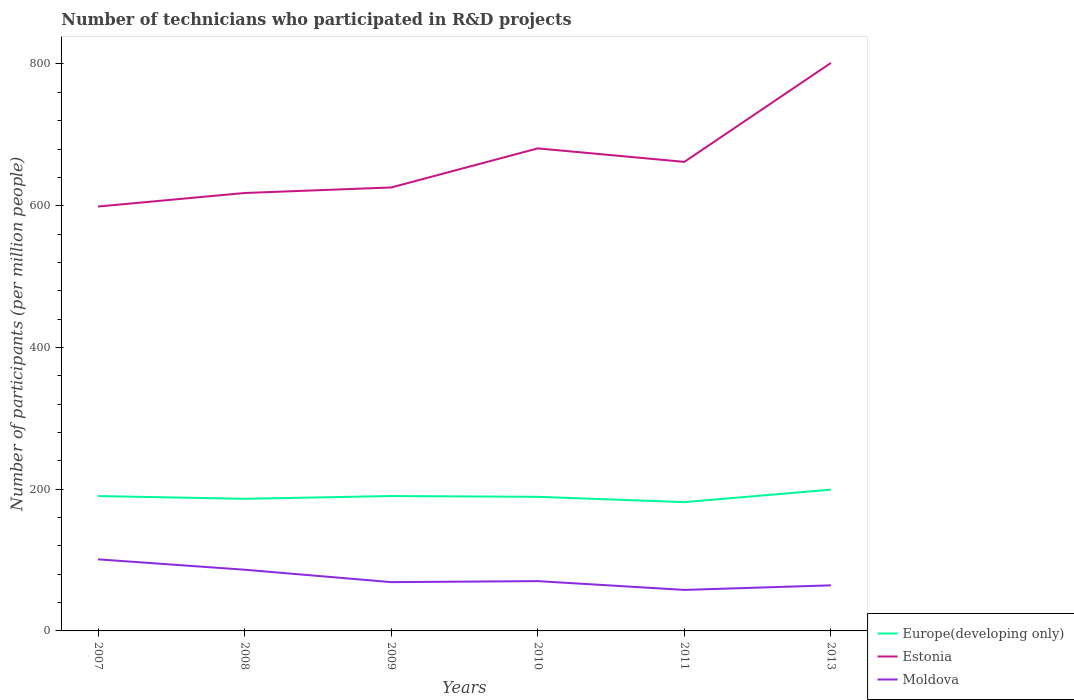Across all years, what is the maximum number of technicians who participated in R&D projects in Moldova?
Provide a short and direct response. 57.87. In which year was the number of technicians who participated in R&D projects in Moldova maximum?
Ensure brevity in your answer.  2011. What is the total number of technicians who participated in R&D projects in Europe(developing only) in the graph?
Provide a short and direct response. -2.8. What is the difference between the highest and the second highest number of technicians who participated in R&D projects in Estonia?
Provide a short and direct response. 202.63. What is the difference between the highest and the lowest number of technicians who participated in R&D projects in Moldova?
Make the answer very short. 2. Is the number of technicians who participated in R&D projects in Europe(developing only) strictly greater than the number of technicians who participated in R&D projects in Estonia over the years?
Offer a very short reply. Yes. How many lines are there?
Make the answer very short. 3. What is the difference between two consecutive major ticks on the Y-axis?
Make the answer very short. 200. Are the values on the major ticks of Y-axis written in scientific E-notation?
Your response must be concise. No. Does the graph contain grids?
Your response must be concise. No. Where does the legend appear in the graph?
Keep it short and to the point. Bottom right. How many legend labels are there?
Make the answer very short. 3. What is the title of the graph?
Provide a succinct answer. Number of technicians who participated in R&D projects. What is the label or title of the Y-axis?
Provide a succinct answer. Number of participants (per million people). What is the Number of participants (per million people) in Europe(developing only) in 2007?
Keep it short and to the point. 190.32. What is the Number of participants (per million people) in Estonia in 2007?
Your answer should be compact. 598.85. What is the Number of participants (per million people) in Moldova in 2007?
Offer a very short reply. 101.01. What is the Number of participants (per million people) of Europe(developing only) in 2008?
Keep it short and to the point. 186.43. What is the Number of participants (per million people) in Estonia in 2008?
Provide a short and direct response. 617.94. What is the Number of participants (per million people) in Moldova in 2008?
Ensure brevity in your answer.  86.35. What is the Number of participants (per million people) of Europe(developing only) in 2009?
Offer a terse response. 190.35. What is the Number of participants (per million people) in Estonia in 2009?
Offer a very short reply. 625.74. What is the Number of participants (per million people) in Moldova in 2009?
Give a very brief answer. 68.85. What is the Number of participants (per million people) of Europe(developing only) in 2010?
Give a very brief answer. 189.23. What is the Number of participants (per million people) of Estonia in 2010?
Make the answer very short. 680.89. What is the Number of participants (per million people) of Moldova in 2010?
Offer a terse response. 70.27. What is the Number of participants (per million people) in Europe(developing only) in 2011?
Offer a terse response. 181.74. What is the Number of participants (per million people) of Estonia in 2011?
Ensure brevity in your answer.  661.86. What is the Number of participants (per million people) of Moldova in 2011?
Make the answer very short. 57.87. What is the Number of participants (per million people) of Europe(developing only) in 2013?
Give a very brief answer. 199.34. What is the Number of participants (per million people) in Estonia in 2013?
Your response must be concise. 801.48. What is the Number of participants (per million people) in Moldova in 2013?
Keep it short and to the point. 64.31. Across all years, what is the maximum Number of participants (per million people) in Europe(developing only)?
Make the answer very short. 199.34. Across all years, what is the maximum Number of participants (per million people) in Estonia?
Keep it short and to the point. 801.48. Across all years, what is the maximum Number of participants (per million people) in Moldova?
Provide a succinct answer. 101.01. Across all years, what is the minimum Number of participants (per million people) in Europe(developing only)?
Offer a very short reply. 181.74. Across all years, what is the minimum Number of participants (per million people) in Estonia?
Provide a succinct answer. 598.85. Across all years, what is the minimum Number of participants (per million people) of Moldova?
Keep it short and to the point. 57.87. What is the total Number of participants (per million people) in Europe(developing only) in the graph?
Provide a succinct answer. 1137.4. What is the total Number of participants (per million people) of Estonia in the graph?
Make the answer very short. 3986.77. What is the total Number of participants (per million people) in Moldova in the graph?
Keep it short and to the point. 448.66. What is the difference between the Number of participants (per million people) in Europe(developing only) in 2007 and that in 2008?
Provide a succinct answer. 3.89. What is the difference between the Number of participants (per million people) in Estonia in 2007 and that in 2008?
Offer a terse response. -19.08. What is the difference between the Number of participants (per million people) of Moldova in 2007 and that in 2008?
Your answer should be compact. 14.66. What is the difference between the Number of participants (per million people) of Europe(developing only) in 2007 and that in 2009?
Provide a succinct answer. -0.04. What is the difference between the Number of participants (per million people) in Estonia in 2007 and that in 2009?
Your response must be concise. -26.89. What is the difference between the Number of participants (per million people) in Moldova in 2007 and that in 2009?
Your response must be concise. 32.16. What is the difference between the Number of participants (per million people) of Europe(developing only) in 2007 and that in 2010?
Provide a short and direct response. 1.09. What is the difference between the Number of participants (per million people) of Estonia in 2007 and that in 2010?
Your answer should be compact. -82.03. What is the difference between the Number of participants (per million people) in Moldova in 2007 and that in 2010?
Provide a succinct answer. 30.74. What is the difference between the Number of participants (per million people) in Europe(developing only) in 2007 and that in 2011?
Offer a very short reply. 8.58. What is the difference between the Number of participants (per million people) in Estonia in 2007 and that in 2011?
Give a very brief answer. -63.01. What is the difference between the Number of participants (per million people) in Moldova in 2007 and that in 2011?
Give a very brief answer. 43.13. What is the difference between the Number of participants (per million people) of Europe(developing only) in 2007 and that in 2013?
Your response must be concise. -9.02. What is the difference between the Number of participants (per million people) of Estonia in 2007 and that in 2013?
Keep it short and to the point. -202.63. What is the difference between the Number of participants (per million people) of Moldova in 2007 and that in 2013?
Offer a terse response. 36.69. What is the difference between the Number of participants (per million people) in Europe(developing only) in 2008 and that in 2009?
Provide a short and direct response. -3.93. What is the difference between the Number of participants (per million people) in Estonia in 2008 and that in 2009?
Your answer should be compact. -7.8. What is the difference between the Number of participants (per million people) of Moldova in 2008 and that in 2009?
Make the answer very short. 17.5. What is the difference between the Number of participants (per million people) of Europe(developing only) in 2008 and that in 2010?
Your response must be concise. -2.8. What is the difference between the Number of participants (per million people) of Estonia in 2008 and that in 2010?
Offer a very short reply. -62.95. What is the difference between the Number of participants (per million people) of Moldova in 2008 and that in 2010?
Your response must be concise. 16.08. What is the difference between the Number of participants (per million people) in Europe(developing only) in 2008 and that in 2011?
Make the answer very short. 4.68. What is the difference between the Number of participants (per million people) in Estonia in 2008 and that in 2011?
Offer a terse response. -43.93. What is the difference between the Number of participants (per million people) of Moldova in 2008 and that in 2011?
Offer a terse response. 28.48. What is the difference between the Number of participants (per million people) in Europe(developing only) in 2008 and that in 2013?
Offer a very short reply. -12.92. What is the difference between the Number of participants (per million people) in Estonia in 2008 and that in 2013?
Make the answer very short. -183.55. What is the difference between the Number of participants (per million people) of Moldova in 2008 and that in 2013?
Provide a short and direct response. 22.04. What is the difference between the Number of participants (per million people) of Europe(developing only) in 2009 and that in 2010?
Make the answer very short. 1.13. What is the difference between the Number of participants (per million people) in Estonia in 2009 and that in 2010?
Offer a very short reply. -55.14. What is the difference between the Number of participants (per million people) in Moldova in 2009 and that in 2010?
Your answer should be compact. -1.42. What is the difference between the Number of participants (per million people) in Europe(developing only) in 2009 and that in 2011?
Your response must be concise. 8.61. What is the difference between the Number of participants (per million people) of Estonia in 2009 and that in 2011?
Your answer should be compact. -36.12. What is the difference between the Number of participants (per million people) of Moldova in 2009 and that in 2011?
Your answer should be very brief. 10.98. What is the difference between the Number of participants (per million people) of Europe(developing only) in 2009 and that in 2013?
Your answer should be very brief. -8.99. What is the difference between the Number of participants (per million people) of Estonia in 2009 and that in 2013?
Your response must be concise. -175.74. What is the difference between the Number of participants (per million people) of Moldova in 2009 and that in 2013?
Your response must be concise. 4.54. What is the difference between the Number of participants (per million people) of Europe(developing only) in 2010 and that in 2011?
Keep it short and to the point. 7.49. What is the difference between the Number of participants (per million people) in Estonia in 2010 and that in 2011?
Your response must be concise. 19.02. What is the difference between the Number of participants (per million people) in Moldova in 2010 and that in 2011?
Your answer should be very brief. 12.39. What is the difference between the Number of participants (per million people) of Europe(developing only) in 2010 and that in 2013?
Give a very brief answer. -10.11. What is the difference between the Number of participants (per million people) of Estonia in 2010 and that in 2013?
Give a very brief answer. -120.6. What is the difference between the Number of participants (per million people) of Moldova in 2010 and that in 2013?
Your answer should be compact. 5.95. What is the difference between the Number of participants (per million people) in Europe(developing only) in 2011 and that in 2013?
Provide a succinct answer. -17.6. What is the difference between the Number of participants (per million people) in Estonia in 2011 and that in 2013?
Ensure brevity in your answer.  -139.62. What is the difference between the Number of participants (per million people) in Moldova in 2011 and that in 2013?
Make the answer very short. -6.44. What is the difference between the Number of participants (per million people) in Europe(developing only) in 2007 and the Number of participants (per million people) in Estonia in 2008?
Offer a terse response. -427.62. What is the difference between the Number of participants (per million people) of Europe(developing only) in 2007 and the Number of participants (per million people) of Moldova in 2008?
Ensure brevity in your answer.  103.97. What is the difference between the Number of participants (per million people) of Estonia in 2007 and the Number of participants (per million people) of Moldova in 2008?
Your answer should be compact. 512.5. What is the difference between the Number of participants (per million people) in Europe(developing only) in 2007 and the Number of participants (per million people) in Estonia in 2009?
Offer a very short reply. -435.43. What is the difference between the Number of participants (per million people) in Europe(developing only) in 2007 and the Number of participants (per million people) in Moldova in 2009?
Your answer should be compact. 121.47. What is the difference between the Number of participants (per million people) of Estonia in 2007 and the Number of participants (per million people) of Moldova in 2009?
Your response must be concise. 530. What is the difference between the Number of participants (per million people) of Europe(developing only) in 2007 and the Number of participants (per million people) of Estonia in 2010?
Provide a short and direct response. -490.57. What is the difference between the Number of participants (per million people) in Europe(developing only) in 2007 and the Number of participants (per million people) in Moldova in 2010?
Your answer should be very brief. 120.05. What is the difference between the Number of participants (per million people) in Estonia in 2007 and the Number of participants (per million people) in Moldova in 2010?
Offer a very short reply. 528.59. What is the difference between the Number of participants (per million people) of Europe(developing only) in 2007 and the Number of participants (per million people) of Estonia in 2011?
Make the answer very short. -471.55. What is the difference between the Number of participants (per million people) in Europe(developing only) in 2007 and the Number of participants (per million people) in Moldova in 2011?
Provide a succinct answer. 132.44. What is the difference between the Number of participants (per million people) in Estonia in 2007 and the Number of participants (per million people) in Moldova in 2011?
Give a very brief answer. 540.98. What is the difference between the Number of participants (per million people) of Europe(developing only) in 2007 and the Number of participants (per million people) of Estonia in 2013?
Ensure brevity in your answer.  -611.17. What is the difference between the Number of participants (per million people) of Europe(developing only) in 2007 and the Number of participants (per million people) of Moldova in 2013?
Offer a terse response. 126. What is the difference between the Number of participants (per million people) in Estonia in 2007 and the Number of participants (per million people) in Moldova in 2013?
Offer a terse response. 534.54. What is the difference between the Number of participants (per million people) of Europe(developing only) in 2008 and the Number of participants (per million people) of Estonia in 2009?
Make the answer very short. -439.32. What is the difference between the Number of participants (per million people) of Europe(developing only) in 2008 and the Number of participants (per million people) of Moldova in 2009?
Offer a very short reply. 117.57. What is the difference between the Number of participants (per million people) of Estonia in 2008 and the Number of participants (per million people) of Moldova in 2009?
Provide a short and direct response. 549.09. What is the difference between the Number of participants (per million people) of Europe(developing only) in 2008 and the Number of participants (per million people) of Estonia in 2010?
Your response must be concise. -494.46. What is the difference between the Number of participants (per million people) of Europe(developing only) in 2008 and the Number of participants (per million people) of Moldova in 2010?
Keep it short and to the point. 116.16. What is the difference between the Number of participants (per million people) in Estonia in 2008 and the Number of participants (per million people) in Moldova in 2010?
Offer a very short reply. 547.67. What is the difference between the Number of participants (per million people) in Europe(developing only) in 2008 and the Number of participants (per million people) in Estonia in 2011?
Make the answer very short. -475.44. What is the difference between the Number of participants (per million people) in Europe(developing only) in 2008 and the Number of participants (per million people) in Moldova in 2011?
Your response must be concise. 128.55. What is the difference between the Number of participants (per million people) of Estonia in 2008 and the Number of participants (per million people) of Moldova in 2011?
Your answer should be compact. 560.06. What is the difference between the Number of participants (per million people) of Europe(developing only) in 2008 and the Number of participants (per million people) of Estonia in 2013?
Your answer should be very brief. -615.06. What is the difference between the Number of participants (per million people) of Europe(developing only) in 2008 and the Number of participants (per million people) of Moldova in 2013?
Give a very brief answer. 122.11. What is the difference between the Number of participants (per million people) of Estonia in 2008 and the Number of participants (per million people) of Moldova in 2013?
Offer a very short reply. 553.62. What is the difference between the Number of participants (per million people) in Europe(developing only) in 2009 and the Number of participants (per million people) in Estonia in 2010?
Provide a succinct answer. -490.53. What is the difference between the Number of participants (per million people) of Europe(developing only) in 2009 and the Number of participants (per million people) of Moldova in 2010?
Your response must be concise. 120.09. What is the difference between the Number of participants (per million people) in Estonia in 2009 and the Number of participants (per million people) in Moldova in 2010?
Keep it short and to the point. 555.48. What is the difference between the Number of participants (per million people) of Europe(developing only) in 2009 and the Number of participants (per million people) of Estonia in 2011?
Provide a short and direct response. -471.51. What is the difference between the Number of participants (per million people) of Europe(developing only) in 2009 and the Number of participants (per million people) of Moldova in 2011?
Offer a terse response. 132.48. What is the difference between the Number of participants (per million people) of Estonia in 2009 and the Number of participants (per million people) of Moldova in 2011?
Keep it short and to the point. 567.87. What is the difference between the Number of participants (per million people) in Europe(developing only) in 2009 and the Number of participants (per million people) in Estonia in 2013?
Your response must be concise. -611.13. What is the difference between the Number of participants (per million people) of Europe(developing only) in 2009 and the Number of participants (per million people) of Moldova in 2013?
Provide a short and direct response. 126.04. What is the difference between the Number of participants (per million people) in Estonia in 2009 and the Number of participants (per million people) in Moldova in 2013?
Your response must be concise. 561.43. What is the difference between the Number of participants (per million people) of Europe(developing only) in 2010 and the Number of participants (per million people) of Estonia in 2011?
Your answer should be compact. -472.64. What is the difference between the Number of participants (per million people) in Europe(developing only) in 2010 and the Number of participants (per million people) in Moldova in 2011?
Your response must be concise. 131.35. What is the difference between the Number of participants (per million people) in Estonia in 2010 and the Number of participants (per million people) in Moldova in 2011?
Keep it short and to the point. 623.01. What is the difference between the Number of participants (per million people) of Europe(developing only) in 2010 and the Number of participants (per million people) of Estonia in 2013?
Offer a very short reply. -612.26. What is the difference between the Number of participants (per million people) in Europe(developing only) in 2010 and the Number of participants (per million people) in Moldova in 2013?
Make the answer very short. 124.91. What is the difference between the Number of participants (per million people) in Estonia in 2010 and the Number of participants (per million people) in Moldova in 2013?
Offer a very short reply. 616.57. What is the difference between the Number of participants (per million people) of Europe(developing only) in 2011 and the Number of participants (per million people) of Estonia in 2013?
Your answer should be compact. -619.74. What is the difference between the Number of participants (per million people) of Europe(developing only) in 2011 and the Number of participants (per million people) of Moldova in 2013?
Give a very brief answer. 117.43. What is the difference between the Number of participants (per million people) in Estonia in 2011 and the Number of participants (per million people) in Moldova in 2013?
Give a very brief answer. 597.55. What is the average Number of participants (per million people) of Europe(developing only) per year?
Offer a terse response. 189.57. What is the average Number of participants (per million people) in Estonia per year?
Keep it short and to the point. 664.46. What is the average Number of participants (per million people) of Moldova per year?
Your answer should be very brief. 74.78. In the year 2007, what is the difference between the Number of participants (per million people) in Europe(developing only) and Number of participants (per million people) in Estonia?
Provide a succinct answer. -408.54. In the year 2007, what is the difference between the Number of participants (per million people) of Europe(developing only) and Number of participants (per million people) of Moldova?
Your response must be concise. 89.31. In the year 2007, what is the difference between the Number of participants (per million people) in Estonia and Number of participants (per million people) in Moldova?
Make the answer very short. 497.85. In the year 2008, what is the difference between the Number of participants (per million people) in Europe(developing only) and Number of participants (per million people) in Estonia?
Offer a very short reply. -431.51. In the year 2008, what is the difference between the Number of participants (per million people) of Europe(developing only) and Number of participants (per million people) of Moldova?
Your answer should be compact. 100.08. In the year 2008, what is the difference between the Number of participants (per million people) of Estonia and Number of participants (per million people) of Moldova?
Offer a terse response. 531.59. In the year 2009, what is the difference between the Number of participants (per million people) of Europe(developing only) and Number of participants (per million people) of Estonia?
Provide a short and direct response. -435.39. In the year 2009, what is the difference between the Number of participants (per million people) in Europe(developing only) and Number of participants (per million people) in Moldova?
Your response must be concise. 121.5. In the year 2009, what is the difference between the Number of participants (per million people) in Estonia and Number of participants (per million people) in Moldova?
Make the answer very short. 556.89. In the year 2010, what is the difference between the Number of participants (per million people) of Europe(developing only) and Number of participants (per million people) of Estonia?
Keep it short and to the point. -491.66. In the year 2010, what is the difference between the Number of participants (per million people) of Europe(developing only) and Number of participants (per million people) of Moldova?
Your answer should be compact. 118.96. In the year 2010, what is the difference between the Number of participants (per million people) of Estonia and Number of participants (per million people) of Moldova?
Offer a very short reply. 610.62. In the year 2011, what is the difference between the Number of participants (per million people) in Europe(developing only) and Number of participants (per million people) in Estonia?
Provide a short and direct response. -480.12. In the year 2011, what is the difference between the Number of participants (per million people) of Europe(developing only) and Number of participants (per million people) of Moldova?
Provide a short and direct response. 123.87. In the year 2011, what is the difference between the Number of participants (per million people) in Estonia and Number of participants (per million people) in Moldova?
Offer a terse response. 603.99. In the year 2013, what is the difference between the Number of participants (per million people) of Europe(developing only) and Number of participants (per million people) of Estonia?
Your answer should be compact. -602.14. In the year 2013, what is the difference between the Number of participants (per million people) in Europe(developing only) and Number of participants (per million people) in Moldova?
Ensure brevity in your answer.  135.03. In the year 2013, what is the difference between the Number of participants (per million people) in Estonia and Number of participants (per million people) in Moldova?
Your answer should be compact. 737.17. What is the ratio of the Number of participants (per million people) of Europe(developing only) in 2007 to that in 2008?
Provide a short and direct response. 1.02. What is the ratio of the Number of participants (per million people) of Estonia in 2007 to that in 2008?
Make the answer very short. 0.97. What is the ratio of the Number of participants (per million people) of Moldova in 2007 to that in 2008?
Your response must be concise. 1.17. What is the ratio of the Number of participants (per million people) of Europe(developing only) in 2007 to that in 2009?
Offer a terse response. 1. What is the ratio of the Number of participants (per million people) in Estonia in 2007 to that in 2009?
Provide a succinct answer. 0.96. What is the ratio of the Number of participants (per million people) of Moldova in 2007 to that in 2009?
Offer a terse response. 1.47. What is the ratio of the Number of participants (per million people) in Europe(developing only) in 2007 to that in 2010?
Provide a short and direct response. 1.01. What is the ratio of the Number of participants (per million people) in Estonia in 2007 to that in 2010?
Give a very brief answer. 0.88. What is the ratio of the Number of participants (per million people) in Moldova in 2007 to that in 2010?
Make the answer very short. 1.44. What is the ratio of the Number of participants (per million people) of Europe(developing only) in 2007 to that in 2011?
Your response must be concise. 1.05. What is the ratio of the Number of participants (per million people) in Estonia in 2007 to that in 2011?
Offer a very short reply. 0.9. What is the ratio of the Number of participants (per million people) of Moldova in 2007 to that in 2011?
Your answer should be very brief. 1.75. What is the ratio of the Number of participants (per million people) in Europe(developing only) in 2007 to that in 2013?
Your answer should be compact. 0.95. What is the ratio of the Number of participants (per million people) in Estonia in 2007 to that in 2013?
Offer a terse response. 0.75. What is the ratio of the Number of participants (per million people) in Moldova in 2007 to that in 2013?
Your answer should be very brief. 1.57. What is the ratio of the Number of participants (per million people) in Europe(developing only) in 2008 to that in 2009?
Your answer should be very brief. 0.98. What is the ratio of the Number of participants (per million people) in Estonia in 2008 to that in 2009?
Your answer should be very brief. 0.99. What is the ratio of the Number of participants (per million people) of Moldova in 2008 to that in 2009?
Your response must be concise. 1.25. What is the ratio of the Number of participants (per million people) of Europe(developing only) in 2008 to that in 2010?
Keep it short and to the point. 0.99. What is the ratio of the Number of participants (per million people) of Estonia in 2008 to that in 2010?
Your answer should be compact. 0.91. What is the ratio of the Number of participants (per million people) in Moldova in 2008 to that in 2010?
Your answer should be compact. 1.23. What is the ratio of the Number of participants (per million people) in Europe(developing only) in 2008 to that in 2011?
Offer a very short reply. 1.03. What is the ratio of the Number of participants (per million people) in Estonia in 2008 to that in 2011?
Offer a terse response. 0.93. What is the ratio of the Number of participants (per million people) of Moldova in 2008 to that in 2011?
Provide a succinct answer. 1.49. What is the ratio of the Number of participants (per million people) of Europe(developing only) in 2008 to that in 2013?
Make the answer very short. 0.94. What is the ratio of the Number of participants (per million people) in Estonia in 2008 to that in 2013?
Provide a succinct answer. 0.77. What is the ratio of the Number of participants (per million people) of Moldova in 2008 to that in 2013?
Ensure brevity in your answer.  1.34. What is the ratio of the Number of participants (per million people) of Estonia in 2009 to that in 2010?
Give a very brief answer. 0.92. What is the ratio of the Number of participants (per million people) of Moldova in 2009 to that in 2010?
Keep it short and to the point. 0.98. What is the ratio of the Number of participants (per million people) of Europe(developing only) in 2009 to that in 2011?
Your response must be concise. 1.05. What is the ratio of the Number of participants (per million people) of Estonia in 2009 to that in 2011?
Your answer should be very brief. 0.95. What is the ratio of the Number of participants (per million people) of Moldova in 2009 to that in 2011?
Make the answer very short. 1.19. What is the ratio of the Number of participants (per million people) of Europe(developing only) in 2009 to that in 2013?
Offer a terse response. 0.95. What is the ratio of the Number of participants (per million people) in Estonia in 2009 to that in 2013?
Your answer should be compact. 0.78. What is the ratio of the Number of participants (per million people) of Moldova in 2009 to that in 2013?
Provide a short and direct response. 1.07. What is the ratio of the Number of participants (per million people) in Europe(developing only) in 2010 to that in 2011?
Your answer should be very brief. 1.04. What is the ratio of the Number of participants (per million people) in Estonia in 2010 to that in 2011?
Your answer should be compact. 1.03. What is the ratio of the Number of participants (per million people) of Moldova in 2010 to that in 2011?
Your answer should be very brief. 1.21. What is the ratio of the Number of participants (per million people) in Europe(developing only) in 2010 to that in 2013?
Keep it short and to the point. 0.95. What is the ratio of the Number of participants (per million people) in Estonia in 2010 to that in 2013?
Provide a short and direct response. 0.85. What is the ratio of the Number of participants (per million people) of Moldova in 2010 to that in 2013?
Provide a succinct answer. 1.09. What is the ratio of the Number of participants (per million people) in Europe(developing only) in 2011 to that in 2013?
Provide a succinct answer. 0.91. What is the ratio of the Number of participants (per million people) in Estonia in 2011 to that in 2013?
Your answer should be compact. 0.83. What is the ratio of the Number of participants (per million people) of Moldova in 2011 to that in 2013?
Offer a very short reply. 0.9. What is the difference between the highest and the second highest Number of participants (per million people) in Europe(developing only)?
Offer a terse response. 8.99. What is the difference between the highest and the second highest Number of participants (per million people) in Estonia?
Ensure brevity in your answer.  120.6. What is the difference between the highest and the second highest Number of participants (per million people) in Moldova?
Your response must be concise. 14.66. What is the difference between the highest and the lowest Number of participants (per million people) in Europe(developing only)?
Give a very brief answer. 17.6. What is the difference between the highest and the lowest Number of participants (per million people) of Estonia?
Make the answer very short. 202.63. What is the difference between the highest and the lowest Number of participants (per million people) of Moldova?
Provide a short and direct response. 43.13. 